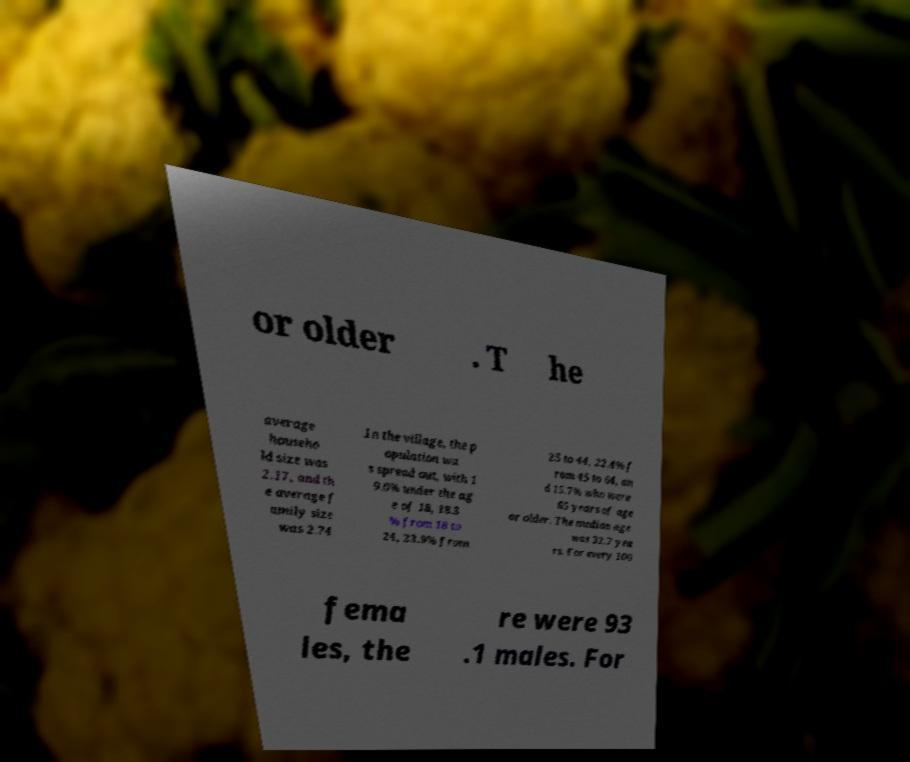Please read and relay the text visible in this image. What does it say? or older . T he average househo ld size was 2.17, and th e average f amily size was 2.74 .In the village, the p opulation wa s spread out, with 1 9.6% under the ag e of 18, 18.3 % from 18 to 24, 23.9% from 25 to 44, 22.4% f rom 45 to 64, an d 15.7% who were 65 years of age or older. The median age was 32.7 yea rs. For every 100 fema les, the re were 93 .1 males. For 